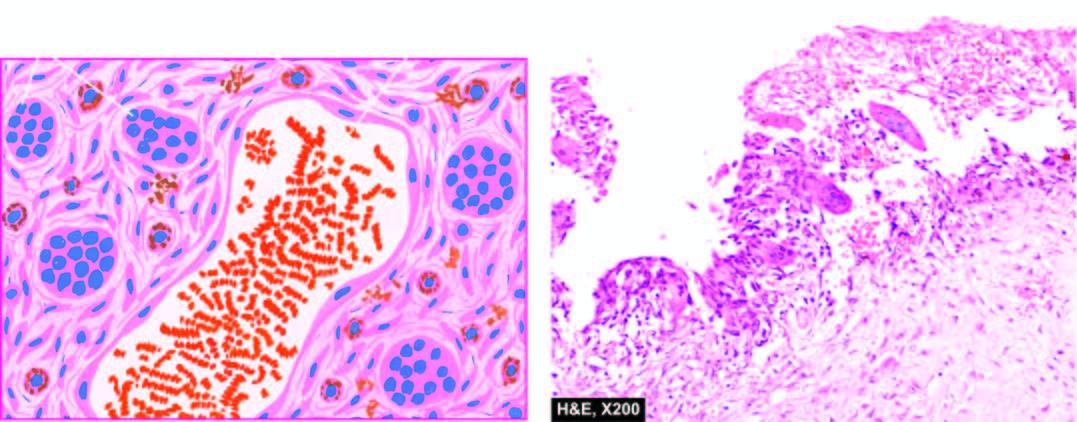s histologic hallmark of lesion presence of aneurysmal spaces filled with blood, partly lined by endothelium and separated by connective tissue septa containing osteoclast-like giant cells along the wall of vascular spaces?
Answer the question using a single word or phrase. Yes 